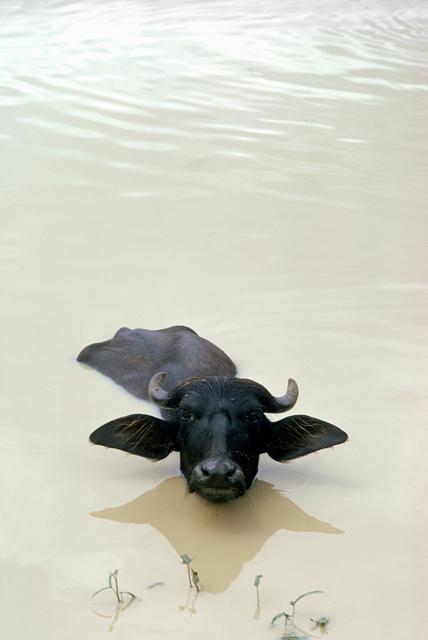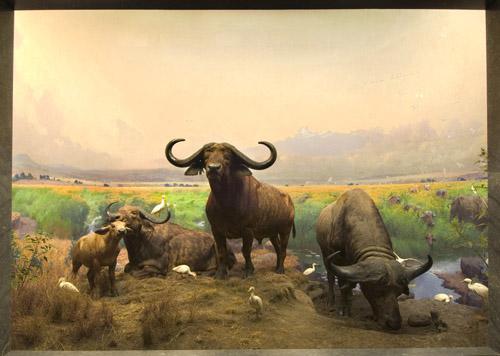The first image is the image on the left, the second image is the image on the right. For the images shown, is this caption "In at least one image there is only a single bull up to its chest in water." true? Answer yes or no. Yes. The first image is the image on the left, the second image is the image on the right. For the images displayed, is the sentence "A cow in the image on the left is walking through the water." factually correct? Answer yes or no. Yes. 